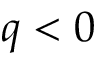Convert formula to latex. <formula><loc_0><loc_0><loc_500><loc_500>q < 0</formula> 